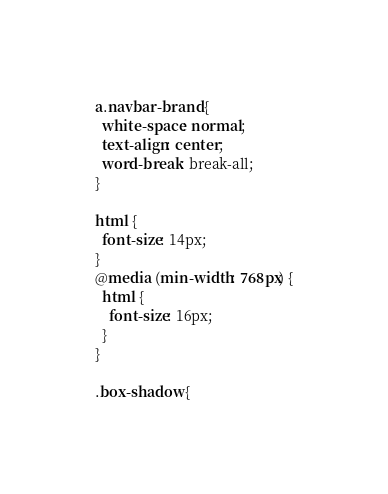<code> <loc_0><loc_0><loc_500><loc_500><_CSS_>

a.navbar-brand {
  white-space: normal;
  text-align: center;
  word-break: break-all;
}

html {
  font-size: 14px;
}
@media (min-width: 768px) {
  html {
    font-size: 16px;
  }
}

.box-shadow {</code> 